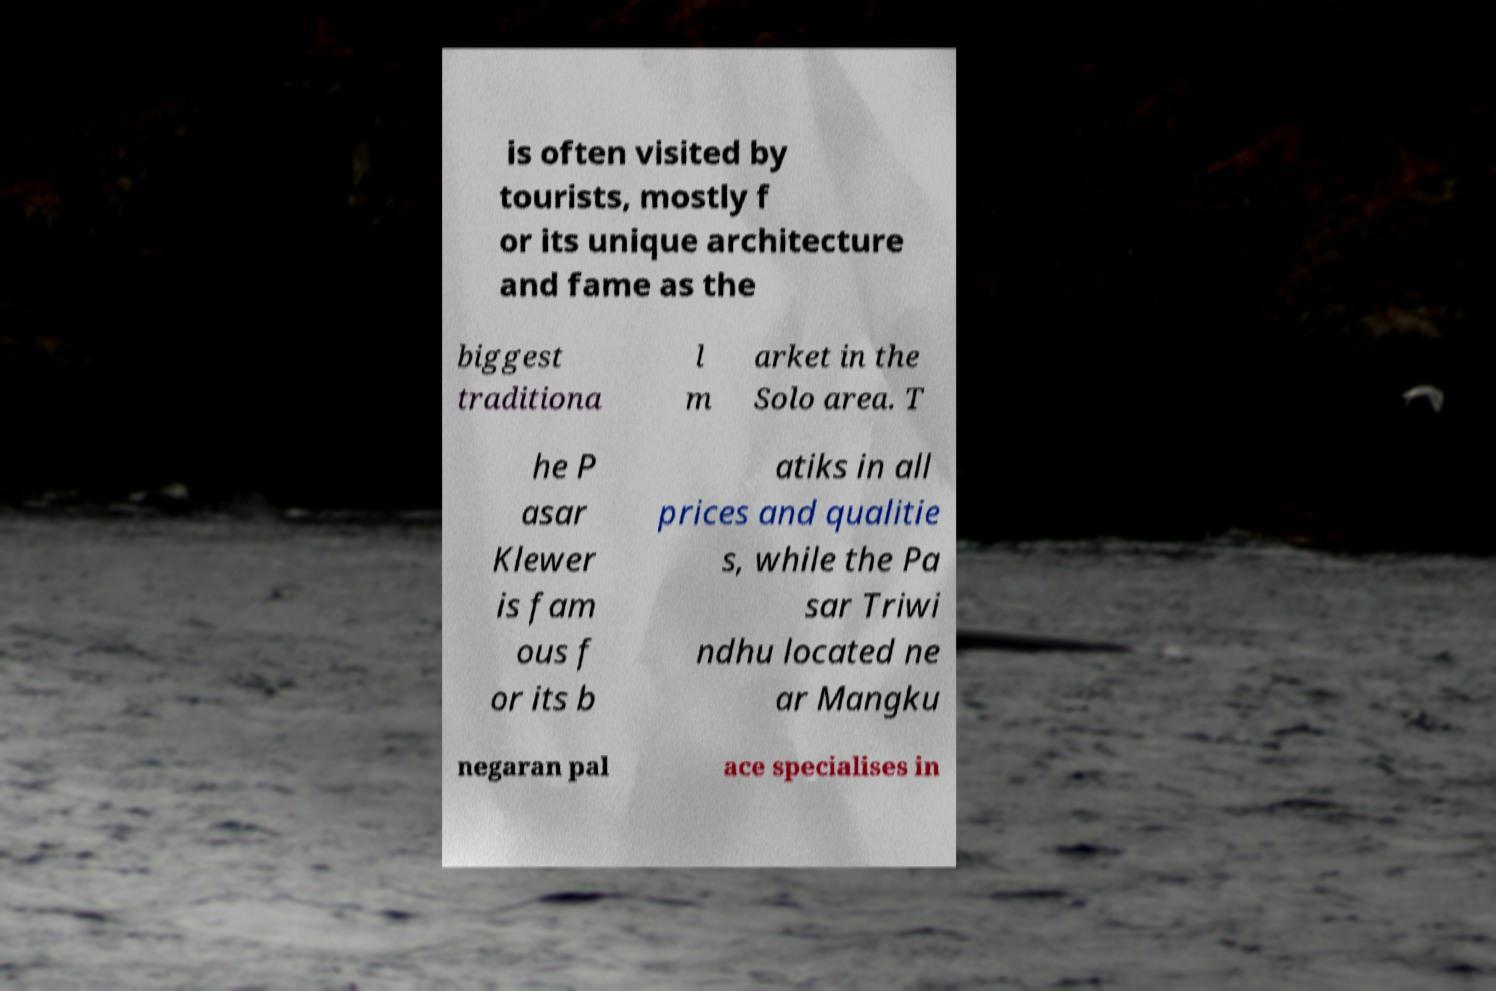There's text embedded in this image that I need extracted. Can you transcribe it verbatim? is often visited by tourists, mostly f or its unique architecture and fame as the biggest traditiona l m arket in the Solo area. T he P asar Klewer is fam ous f or its b atiks in all prices and qualitie s, while the Pa sar Triwi ndhu located ne ar Mangku negaran pal ace specialises in 